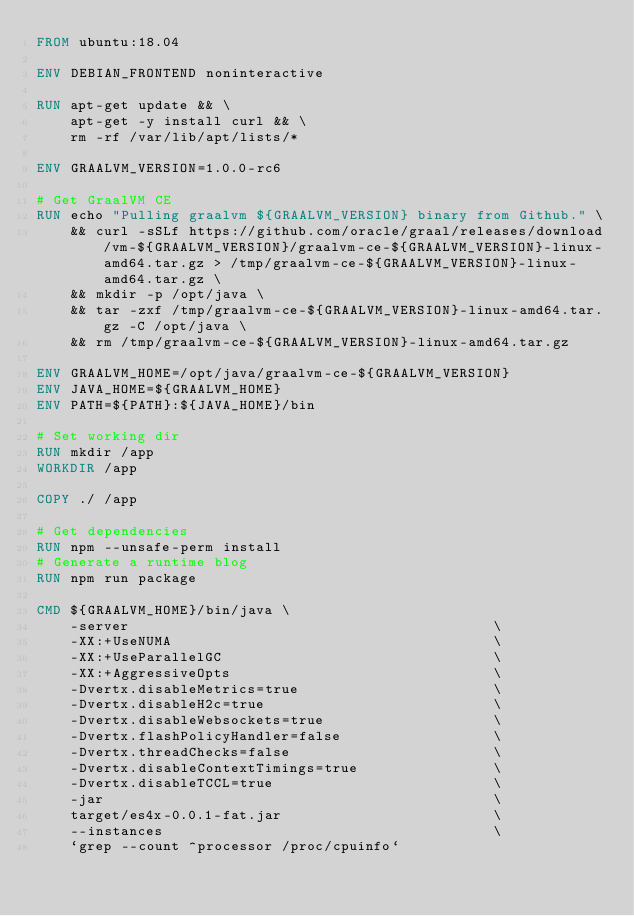Convert code to text. <code><loc_0><loc_0><loc_500><loc_500><_Dockerfile_>FROM ubuntu:18.04

ENV DEBIAN_FRONTEND noninteractive

RUN apt-get update && \
    apt-get -y install curl && \
    rm -rf /var/lib/apt/lists/*

ENV GRAALVM_VERSION=1.0.0-rc6

# Get GraalVM CE
RUN echo "Pulling graalvm ${GRAALVM_VERSION} binary from Github." \
    && curl -sSLf https://github.com/oracle/graal/releases/download/vm-${GRAALVM_VERSION}/graalvm-ce-${GRAALVM_VERSION}-linux-amd64.tar.gz > /tmp/graalvm-ce-${GRAALVM_VERSION}-linux-amd64.tar.gz \
    && mkdir -p /opt/java \
    && tar -zxf /tmp/graalvm-ce-${GRAALVM_VERSION}-linux-amd64.tar.gz -C /opt/java \
    && rm /tmp/graalvm-ce-${GRAALVM_VERSION}-linux-amd64.tar.gz

ENV GRAALVM_HOME=/opt/java/graalvm-ce-${GRAALVM_VERSION}
ENV JAVA_HOME=${GRAALVM_HOME}
ENV PATH=${PATH}:${JAVA_HOME}/bin

# Set working dir
RUN mkdir /app
WORKDIR /app

COPY ./ /app

# Get dependencies
RUN npm --unsafe-perm install
# Generate a runtime blog
RUN npm run package

CMD ${GRAALVM_HOME}/bin/java \
    -server                                           \
    -XX:+UseNUMA                                      \
    -XX:+UseParallelGC                                \
    -XX:+AggressiveOpts                               \
    -Dvertx.disableMetrics=true                       \
    -Dvertx.disableH2c=true                           \
    -Dvertx.disableWebsockets=true                    \
    -Dvertx.flashPolicyHandler=false                  \
    -Dvertx.threadChecks=false                        \
    -Dvertx.disableContextTimings=true                \
    -Dvertx.disableTCCL=true                          \
    -jar                                              \
    target/es4x-0.0.1-fat.jar                         \
    --instances                                       \
    `grep --count ^processor /proc/cpuinfo`</code> 